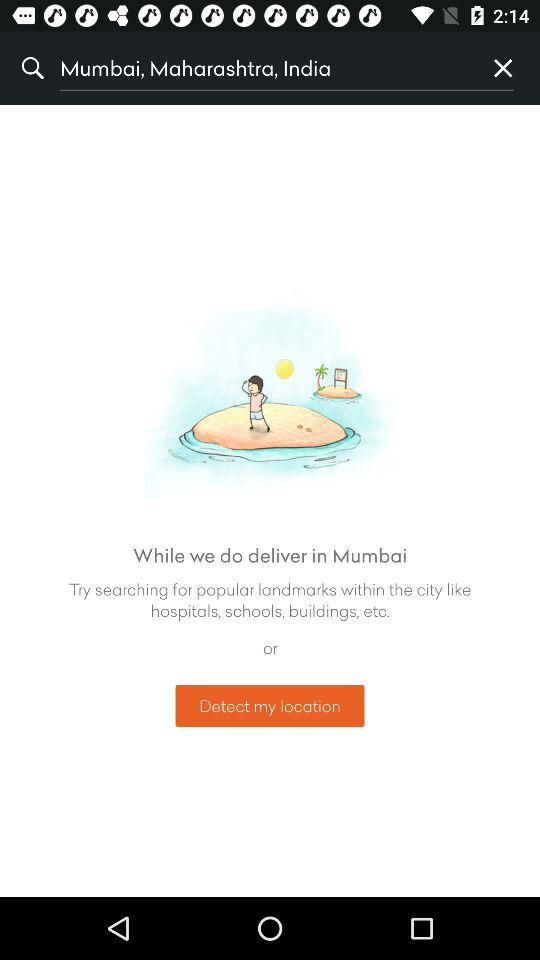What is the searched location? The searched location is Mumbai, Maharashtra, India. 